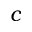Convert formula to latex. <formula><loc_0><loc_0><loc_500><loc_500>c</formula> 